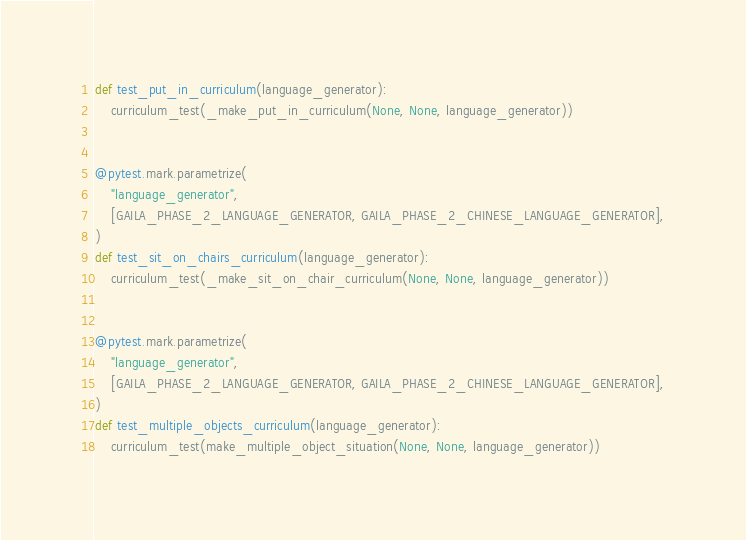<code> <loc_0><loc_0><loc_500><loc_500><_Python_>def test_put_in_curriculum(language_generator):
    curriculum_test(_make_put_in_curriculum(None, None, language_generator))


@pytest.mark.parametrize(
    "language_generator",
    [GAILA_PHASE_2_LANGUAGE_GENERATOR, GAILA_PHASE_2_CHINESE_LANGUAGE_GENERATOR],
)
def test_sit_on_chairs_curriculum(language_generator):
    curriculum_test(_make_sit_on_chair_curriculum(None, None, language_generator))


@pytest.mark.parametrize(
    "language_generator",
    [GAILA_PHASE_2_LANGUAGE_GENERATOR, GAILA_PHASE_2_CHINESE_LANGUAGE_GENERATOR],
)
def test_multiple_objects_curriculum(language_generator):
    curriculum_test(make_multiple_object_situation(None, None, language_generator))
</code> 